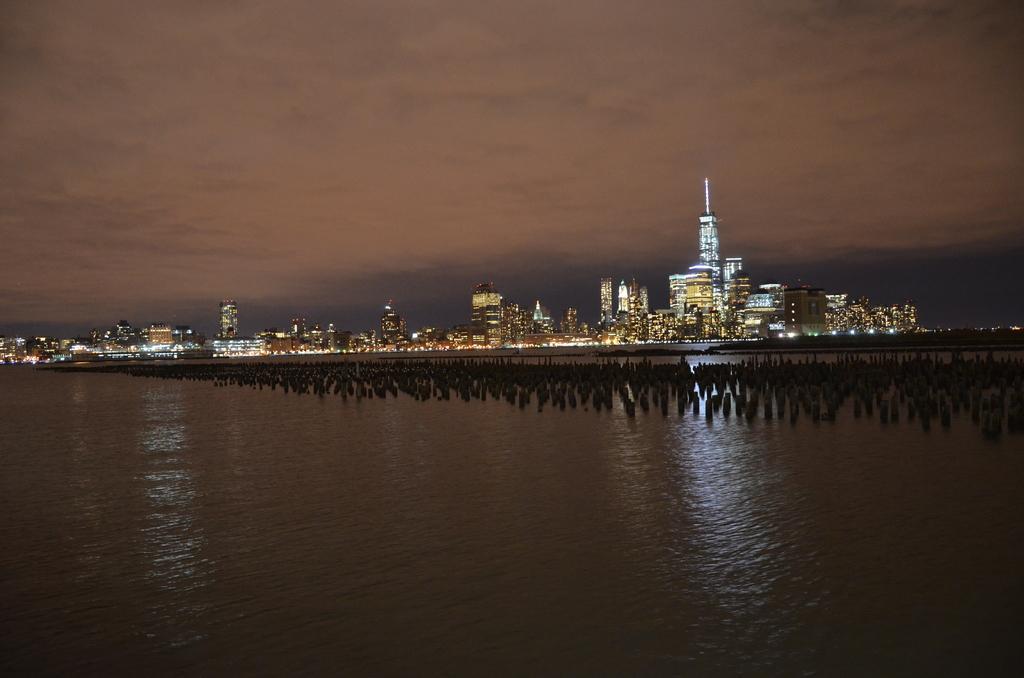Could you give a brief overview of what you see in this image? At the bottom of the picture, we see water and this water might be in the sea. In the middle, it seems like the cement blocks. There are buildings, towers and the lights in the background. At the top, we see the sky and the clouds. This picture might be clicked in the dark. 